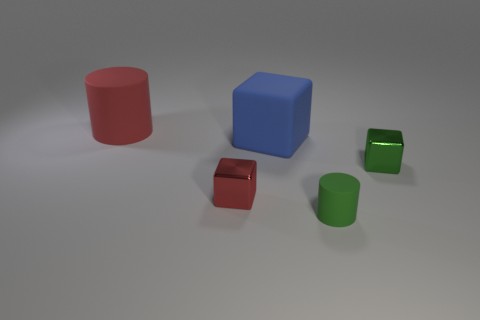Subtract all green metal blocks. How many blocks are left? 2 Add 2 tiny purple metal blocks. How many objects exist? 7 Subtract all blocks. How many objects are left? 2 Add 3 large cyan matte cylinders. How many large cyan matte cylinders exist? 3 Subtract 0 brown cubes. How many objects are left? 5 Subtract all small cyan spheres. Subtract all large rubber things. How many objects are left? 3 Add 4 rubber cylinders. How many rubber cylinders are left? 6 